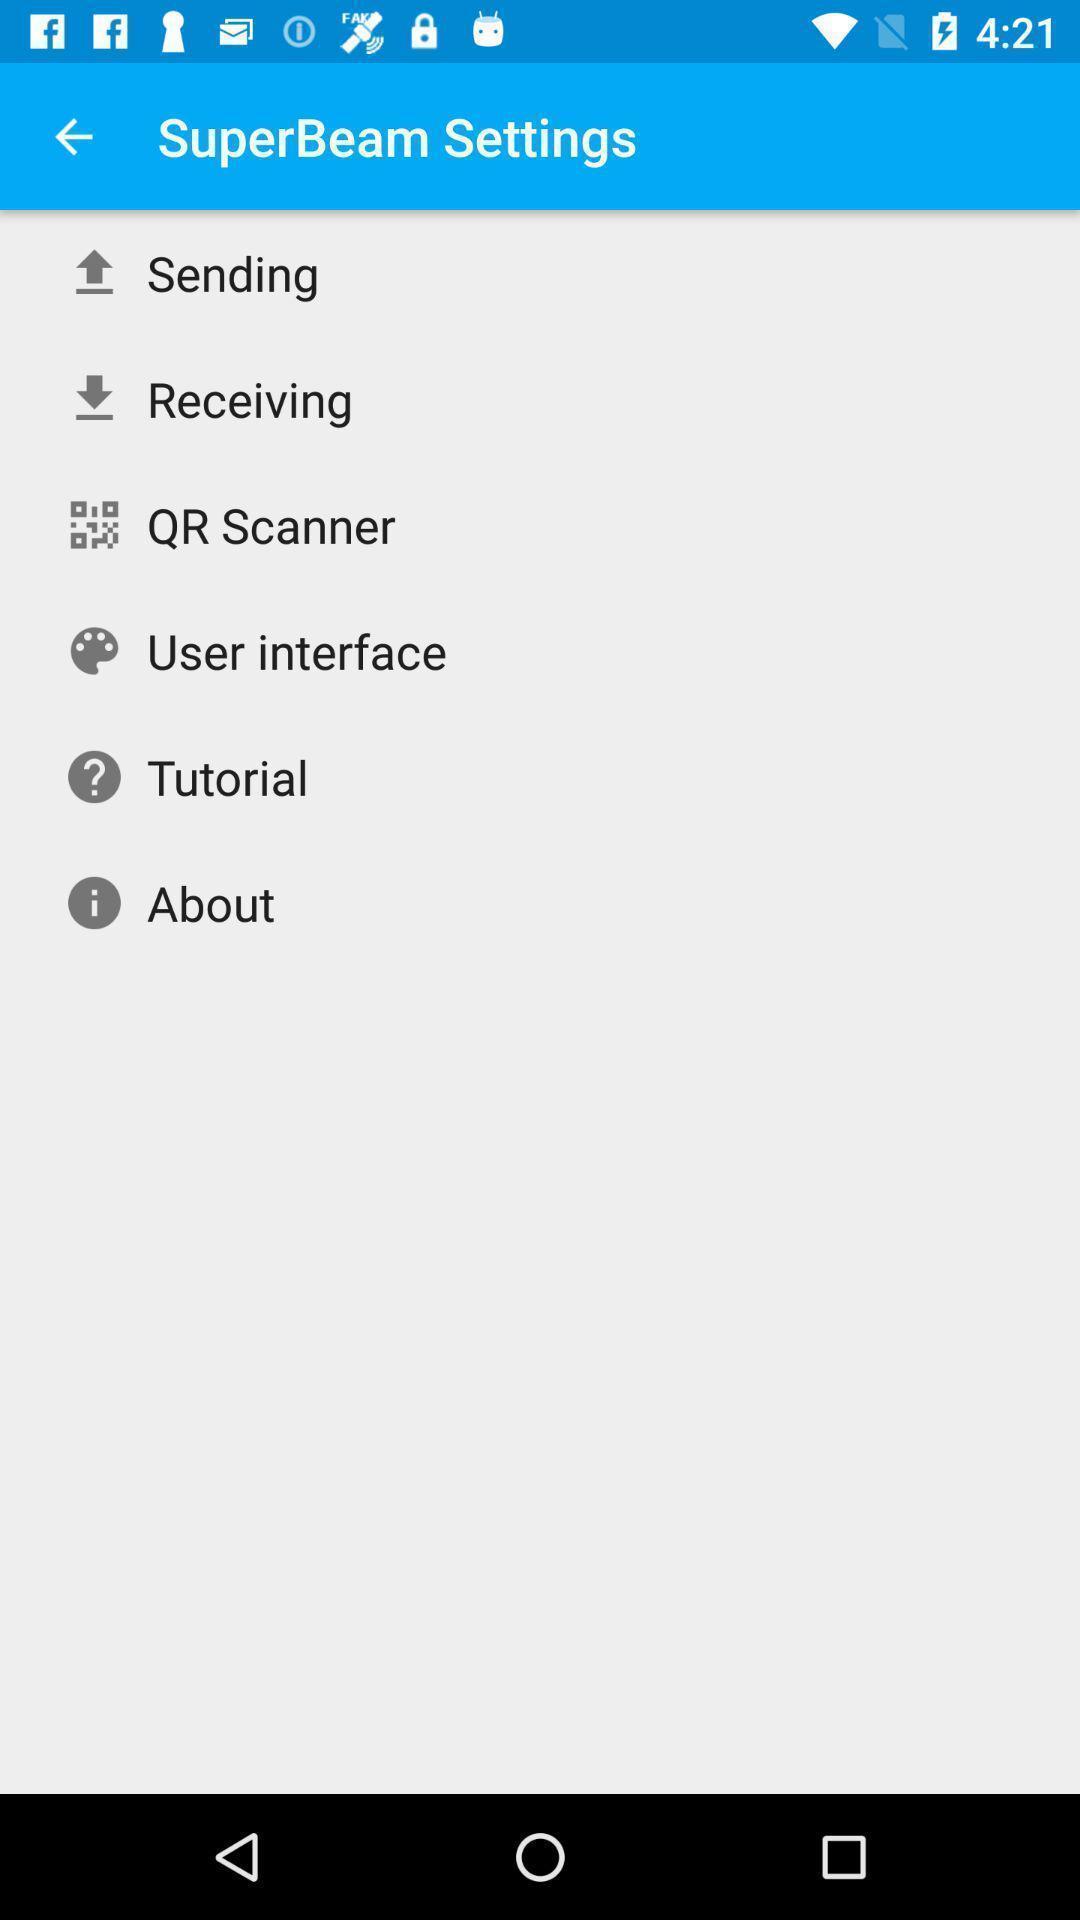Provide a textual representation of this image. Screen showing list of settings. 